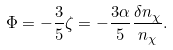<formula> <loc_0><loc_0><loc_500><loc_500>\Phi = - \frac { 3 } { 5 } \zeta = - \frac { 3 \alpha } { 5 } \frac { \delta n _ { \chi } } { n _ { \chi } } .</formula> 